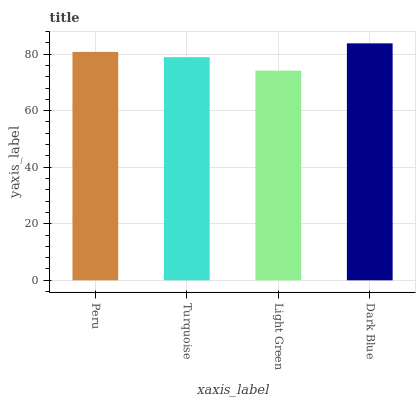Is Turquoise the minimum?
Answer yes or no. No. Is Turquoise the maximum?
Answer yes or no. No. Is Peru greater than Turquoise?
Answer yes or no. Yes. Is Turquoise less than Peru?
Answer yes or no. Yes. Is Turquoise greater than Peru?
Answer yes or no. No. Is Peru less than Turquoise?
Answer yes or no. No. Is Peru the high median?
Answer yes or no. Yes. Is Turquoise the low median?
Answer yes or no. Yes. Is Light Green the high median?
Answer yes or no. No. Is Light Green the low median?
Answer yes or no. No. 